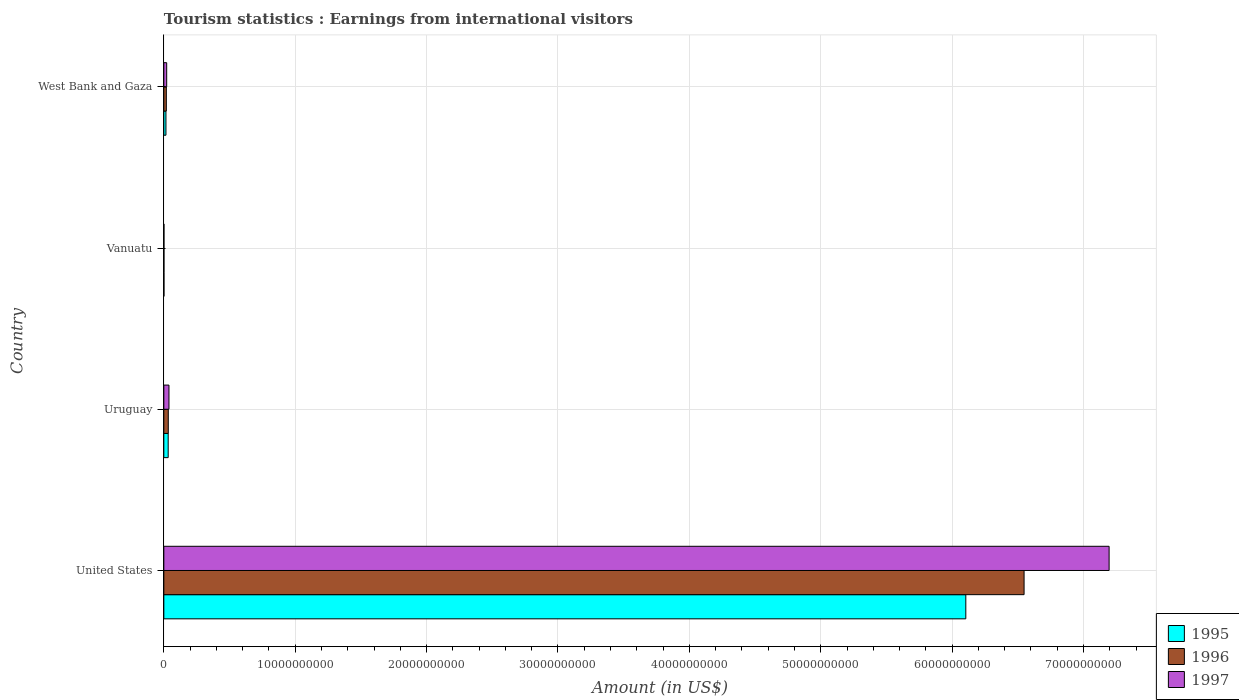How many groups of bars are there?
Make the answer very short. 4. Are the number of bars on each tick of the Y-axis equal?
Your answer should be compact. Yes. How many bars are there on the 1st tick from the top?
Make the answer very short. 3. What is the label of the 1st group of bars from the top?
Provide a short and direct response. West Bank and Gaza. In how many cases, is the number of bars for a given country not equal to the number of legend labels?
Ensure brevity in your answer.  0. What is the earnings from international visitors in 1995 in United States?
Offer a very short reply. 6.10e+1. Across all countries, what is the maximum earnings from international visitors in 1997?
Provide a short and direct response. 7.19e+1. In which country was the earnings from international visitors in 1996 maximum?
Your answer should be very brief. United States. In which country was the earnings from international visitors in 1996 minimum?
Give a very brief answer. Vanuatu. What is the total earnings from international visitors in 1997 in the graph?
Keep it short and to the point. 7.26e+1. What is the difference between the earnings from international visitors in 1996 in Vanuatu and that in West Bank and Gaza?
Provide a short and direct response. -1.81e+08. What is the difference between the earnings from international visitors in 1996 in West Bank and Gaza and the earnings from international visitors in 1995 in Uruguay?
Your answer should be very brief. -1.41e+08. What is the average earnings from international visitors in 1995 per country?
Ensure brevity in your answer.  1.54e+1. What is the difference between the earnings from international visitors in 1995 and earnings from international visitors in 1996 in United States?
Provide a succinct answer. -4.44e+09. In how many countries, is the earnings from international visitors in 1995 greater than 12000000000 US$?
Offer a very short reply. 1. What is the ratio of the earnings from international visitors in 1996 in United States to that in Uruguay?
Your answer should be compact. 193.15. What is the difference between the highest and the second highest earnings from international visitors in 1995?
Keep it short and to the point. 6.07e+1. What is the difference between the highest and the lowest earnings from international visitors in 1995?
Provide a succinct answer. 6.10e+1. In how many countries, is the earnings from international visitors in 1997 greater than the average earnings from international visitors in 1997 taken over all countries?
Make the answer very short. 1. What does the 3rd bar from the top in Uruguay represents?
Provide a succinct answer. 1995. What does the 3rd bar from the bottom in Uruguay represents?
Offer a very short reply. 1997. Is it the case that in every country, the sum of the earnings from international visitors in 1997 and earnings from international visitors in 1996 is greater than the earnings from international visitors in 1995?
Your answer should be compact. Yes. What is the difference between two consecutive major ticks on the X-axis?
Offer a very short reply. 1.00e+1. Are the values on the major ticks of X-axis written in scientific E-notation?
Make the answer very short. No. Does the graph contain grids?
Provide a succinct answer. Yes. How many legend labels are there?
Make the answer very short. 3. How are the legend labels stacked?
Your answer should be compact. Vertical. What is the title of the graph?
Keep it short and to the point. Tourism statistics : Earnings from international visitors. Does "2007" appear as one of the legend labels in the graph?
Offer a very short reply. No. What is the label or title of the X-axis?
Give a very brief answer. Amount (in US$). What is the label or title of the Y-axis?
Keep it short and to the point. Country. What is the Amount (in US$) of 1995 in United States?
Your response must be concise. 6.10e+1. What is the Amount (in US$) of 1996 in United States?
Provide a short and direct response. 6.55e+1. What is the Amount (in US$) of 1997 in United States?
Your response must be concise. 7.19e+1. What is the Amount (in US$) of 1995 in Uruguay?
Your response must be concise. 3.32e+08. What is the Amount (in US$) of 1996 in Uruguay?
Make the answer very short. 3.39e+08. What is the Amount (in US$) of 1997 in Uruguay?
Your response must be concise. 3.91e+08. What is the Amount (in US$) in 1996 in Vanuatu?
Offer a terse response. 1.00e+07. What is the Amount (in US$) of 1995 in West Bank and Gaza?
Give a very brief answer. 1.62e+08. What is the Amount (in US$) in 1996 in West Bank and Gaza?
Your answer should be compact. 1.91e+08. What is the Amount (in US$) of 1997 in West Bank and Gaza?
Your answer should be very brief. 2.18e+08. Across all countries, what is the maximum Amount (in US$) of 1995?
Give a very brief answer. 6.10e+1. Across all countries, what is the maximum Amount (in US$) in 1996?
Give a very brief answer. 6.55e+1. Across all countries, what is the maximum Amount (in US$) in 1997?
Offer a very short reply. 7.19e+1. Across all countries, what is the minimum Amount (in US$) of 1995?
Your answer should be very brief. 1.00e+07. Across all countries, what is the minimum Amount (in US$) of 1996?
Provide a short and direct response. 1.00e+07. Across all countries, what is the minimum Amount (in US$) of 1997?
Offer a very short reply. 1.00e+07. What is the total Amount (in US$) in 1995 in the graph?
Your answer should be very brief. 6.15e+1. What is the total Amount (in US$) in 1996 in the graph?
Provide a succinct answer. 6.60e+1. What is the total Amount (in US$) in 1997 in the graph?
Offer a very short reply. 7.26e+1. What is the difference between the Amount (in US$) in 1995 in United States and that in Uruguay?
Your response must be concise. 6.07e+1. What is the difference between the Amount (in US$) in 1996 in United States and that in Uruguay?
Provide a short and direct response. 6.51e+1. What is the difference between the Amount (in US$) of 1997 in United States and that in Uruguay?
Your answer should be very brief. 7.16e+1. What is the difference between the Amount (in US$) in 1995 in United States and that in Vanuatu?
Provide a short and direct response. 6.10e+1. What is the difference between the Amount (in US$) in 1996 in United States and that in Vanuatu?
Make the answer very short. 6.55e+1. What is the difference between the Amount (in US$) of 1997 in United States and that in Vanuatu?
Provide a succinct answer. 7.19e+1. What is the difference between the Amount (in US$) of 1995 in United States and that in West Bank and Gaza?
Your answer should be compact. 6.09e+1. What is the difference between the Amount (in US$) in 1996 in United States and that in West Bank and Gaza?
Make the answer very short. 6.53e+1. What is the difference between the Amount (in US$) in 1997 in United States and that in West Bank and Gaza?
Offer a very short reply. 7.17e+1. What is the difference between the Amount (in US$) in 1995 in Uruguay and that in Vanuatu?
Make the answer very short. 3.22e+08. What is the difference between the Amount (in US$) in 1996 in Uruguay and that in Vanuatu?
Your answer should be compact. 3.29e+08. What is the difference between the Amount (in US$) in 1997 in Uruguay and that in Vanuatu?
Offer a terse response. 3.81e+08. What is the difference between the Amount (in US$) of 1995 in Uruguay and that in West Bank and Gaza?
Provide a short and direct response. 1.70e+08. What is the difference between the Amount (in US$) of 1996 in Uruguay and that in West Bank and Gaza?
Ensure brevity in your answer.  1.48e+08. What is the difference between the Amount (in US$) in 1997 in Uruguay and that in West Bank and Gaza?
Your response must be concise. 1.73e+08. What is the difference between the Amount (in US$) in 1995 in Vanuatu and that in West Bank and Gaza?
Your answer should be compact. -1.52e+08. What is the difference between the Amount (in US$) in 1996 in Vanuatu and that in West Bank and Gaza?
Make the answer very short. -1.81e+08. What is the difference between the Amount (in US$) in 1997 in Vanuatu and that in West Bank and Gaza?
Your response must be concise. -2.08e+08. What is the difference between the Amount (in US$) in 1995 in United States and the Amount (in US$) in 1996 in Uruguay?
Provide a succinct answer. 6.07e+1. What is the difference between the Amount (in US$) of 1995 in United States and the Amount (in US$) of 1997 in Uruguay?
Offer a terse response. 6.07e+1. What is the difference between the Amount (in US$) in 1996 in United States and the Amount (in US$) in 1997 in Uruguay?
Ensure brevity in your answer.  6.51e+1. What is the difference between the Amount (in US$) in 1995 in United States and the Amount (in US$) in 1996 in Vanuatu?
Offer a terse response. 6.10e+1. What is the difference between the Amount (in US$) of 1995 in United States and the Amount (in US$) of 1997 in Vanuatu?
Make the answer very short. 6.10e+1. What is the difference between the Amount (in US$) of 1996 in United States and the Amount (in US$) of 1997 in Vanuatu?
Ensure brevity in your answer.  6.55e+1. What is the difference between the Amount (in US$) in 1995 in United States and the Amount (in US$) in 1996 in West Bank and Gaza?
Offer a terse response. 6.09e+1. What is the difference between the Amount (in US$) in 1995 in United States and the Amount (in US$) in 1997 in West Bank and Gaza?
Your answer should be very brief. 6.08e+1. What is the difference between the Amount (in US$) in 1996 in United States and the Amount (in US$) in 1997 in West Bank and Gaza?
Your answer should be compact. 6.53e+1. What is the difference between the Amount (in US$) of 1995 in Uruguay and the Amount (in US$) of 1996 in Vanuatu?
Your answer should be compact. 3.22e+08. What is the difference between the Amount (in US$) in 1995 in Uruguay and the Amount (in US$) in 1997 in Vanuatu?
Your answer should be compact. 3.22e+08. What is the difference between the Amount (in US$) in 1996 in Uruguay and the Amount (in US$) in 1997 in Vanuatu?
Offer a very short reply. 3.29e+08. What is the difference between the Amount (in US$) of 1995 in Uruguay and the Amount (in US$) of 1996 in West Bank and Gaza?
Offer a very short reply. 1.41e+08. What is the difference between the Amount (in US$) in 1995 in Uruguay and the Amount (in US$) in 1997 in West Bank and Gaza?
Your response must be concise. 1.14e+08. What is the difference between the Amount (in US$) of 1996 in Uruguay and the Amount (in US$) of 1997 in West Bank and Gaza?
Provide a succinct answer. 1.21e+08. What is the difference between the Amount (in US$) in 1995 in Vanuatu and the Amount (in US$) in 1996 in West Bank and Gaza?
Provide a short and direct response. -1.81e+08. What is the difference between the Amount (in US$) in 1995 in Vanuatu and the Amount (in US$) in 1997 in West Bank and Gaza?
Keep it short and to the point. -2.08e+08. What is the difference between the Amount (in US$) of 1996 in Vanuatu and the Amount (in US$) of 1997 in West Bank and Gaza?
Make the answer very short. -2.08e+08. What is the average Amount (in US$) of 1995 per country?
Give a very brief answer. 1.54e+1. What is the average Amount (in US$) in 1996 per country?
Provide a succinct answer. 1.65e+1. What is the average Amount (in US$) of 1997 per country?
Keep it short and to the point. 1.81e+1. What is the difference between the Amount (in US$) of 1995 and Amount (in US$) of 1996 in United States?
Offer a very short reply. -4.44e+09. What is the difference between the Amount (in US$) of 1995 and Amount (in US$) of 1997 in United States?
Your answer should be very brief. -1.09e+1. What is the difference between the Amount (in US$) in 1996 and Amount (in US$) in 1997 in United States?
Your response must be concise. -6.47e+09. What is the difference between the Amount (in US$) in 1995 and Amount (in US$) in 1996 in Uruguay?
Your answer should be very brief. -7.00e+06. What is the difference between the Amount (in US$) in 1995 and Amount (in US$) in 1997 in Uruguay?
Offer a terse response. -5.90e+07. What is the difference between the Amount (in US$) of 1996 and Amount (in US$) of 1997 in Uruguay?
Your answer should be compact. -5.20e+07. What is the difference between the Amount (in US$) of 1995 and Amount (in US$) of 1996 in West Bank and Gaza?
Your response must be concise. -2.90e+07. What is the difference between the Amount (in US$) in 1995 and Amount (in US$) in 1997 in West Bank and Gaza?
Your answer should be very brief. -5.60e+07. What is the difference between the Amount (in US$) in 1996 and Amount (in US$) in 1997 in West Bank and Gaza?
Make the answer very short. -2.70e+07. What is the ratio of the Amount (in US$) in 1995 in United States to that in Uruguay?
Provide a succinct answer. 183.86. What is the ratio of the Amount (in US$) of 1996 in United States to that in Uruguay?
Keep it short and to the point. 193.15. What is the ratio of the Amount (in US$) in 1997 in United States to that in Uruguay?
Give a very brief answer. 184.01. What is the ratio of the Amount (in US$) of 1995 in United States to that in Vanuatu?
Offer a terse response. 6104.2. What is the ratio of the Amount (in US$) in 1996 in United States to that in Vanuatu?
Keep it short and to the point. 6547.7. What is the ratio of the Amount (in US$) in 1997 in United States to that in Vanuatu?
Provide a succinct answer. 7194.8. What is the ratio of the Amount (in US$) of 1995 in United States to that in West Bank and Gaza?
Your response must be concise. 376.8. What is the ratio of the Amount (in US$) of 1996 in United States to that in West Bank and Gaza?
Give a very brief answer. 342.81. What is the ratio of the Amount (in US$) in 1997 in United States to that in West Bank and Gaza?
Your response must be concise. 330.04. What is the ratio of the Amount (in US$) of 1995 in Uruguay to that in Vanuatu?
Provide a short and direct response. 33.2. What is the ratio of the Amount (in US$) of 1996 in Uruguay to that in Vanuatu?
Offer a terse response. 33.9. What is the ratio of the Amount (in US$) in 1997 in Uruguay to that in Vanuatu?
Your response must be concise. 39.1. What is the ratio of the Amount (in US$) in 1995 in Uruguay to that in West Bank and Gaza?
Give a very brief answer. 2.05. What is the ratio of the Amount (in US$) of 1996 in Uruguay to that in West Bank and Gaza?
Ensure brevity in your answer.  1.77. What is the ratio of the Amount (in US$) in 1997 in Uruguay to that in West Bank and Gaza?
Provide a succinct answer. 1.79. What is the ratio of the Amount (in US$) of 1995 in Vanuatu to that in West Bank and Gaza?
Give a very brief answer. 0.06. What is the ratio of the Amount (in US$) of 1996 in Vanuatu to that in West Bank and Gaza?
Your answer should be very brief. 0.05. What is the ratio of the Amount (in US$) of 1997 in Vanuatu to that in West Bank and Gaza?
Ensure brevity in your answer.  0.05. What is the difference between the highest and the second highest Amount (in US$) in 1995?
Offer a terse response. 6.07e+1. What is the difference between the highest and the second highest Amount (in US$) of 1996?
Your answer should be compact. 6.51e+1. What is the difference between the highest and the second highest Amount (in US$) of 1997?
Keep it short and to the point. 7.16e+1. What is the difference between the highest and the lowest Amount (in US$) in 1995?
Provide a short and direct response. 6.10e+1. What is the difference between the highest and the lowest Amount (in US$) of 1996?
Your response must be concise. 6.55e+1. What is the difference between the highest and the lowest Amount (in US$) of 1997?
Your answer should be compact. 7.19e+1. 